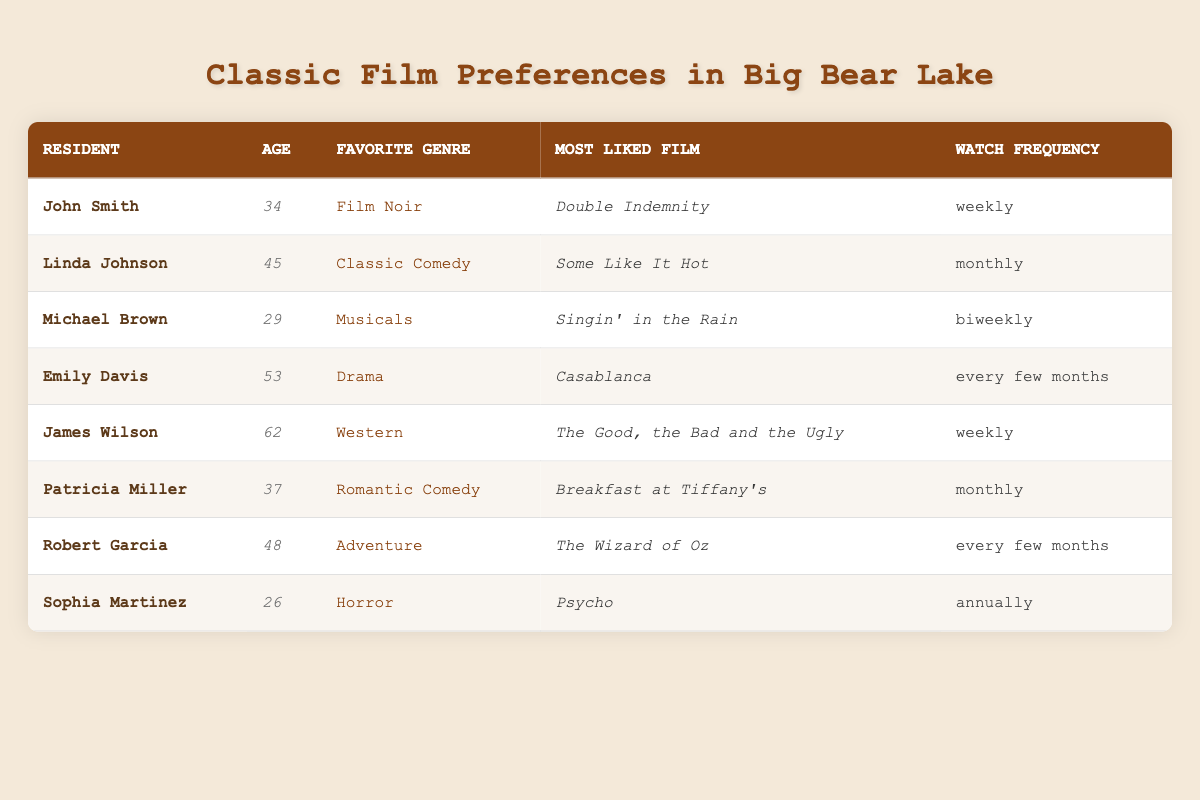What is John Smith's favorite genre? John Smith's favorite genre is listed in the table under the "Favorite Genre" column for his row. The value is "Film Noir".
Answer: Film Noir How many residents prefer Drama as their favorite genre? Looking through the table, only Emily Davis has "Drama" listed as her favorite genre. Therefore, there is just one resident who prefers Drama.
Answer: 1 Which film does Patricia Miller like the most? Patricia Miller's most liked film is found in her row under the "Most Liked Film" column. The value is "Breakfast at Tiffany's".
Answer: Breakfast at Tiffany's Is there anyone who watches films annually? Sophia Martinez has "Annually" listed in the "Watch Frequency" column. Thus, there is indeed a resident who watches films annually.
Answer: Yes What is the average age of residents who watch films weekly? The residents who watch films weekly are John Smith (34) and James Wilson (62). The ages are summed (34 + 62 = 96) and then averaged (96 / 2 = 48).
Answer: 48 Which genre has the highest frequency of watching films among the residents listed? The residents watching films weekly are John Smith (Film Noir) and James Wilson (Western), while Linda Johnson and Patricia Miller watch monthly (Classic Comedy and Romantic Comedy), and others have lesser frequencies. Therefore, the genres with the highest frequency are Film Noir and Western with a frequency of weekly.
Answer: Film Noir and Western What is the most common favorite genre among the surveyed residents? Counting the preferences in the table: Film Noir, Classic Comedy, Musicals, Drama, Western, Romantic Comedy, Adventure, and Horror are the genres. Each genre is unique to its resident, thus there isn't a common genre across multiple residents. Each genre is represented once.
Answer: No common genre How many residents were surveyed in total? Count the number of rows in the table under the "survey_results". There are a total of 8 residents listed.
Answer: 8 What is the most liked film in the Drama genre? Upon checking, "Casablanca" is the most liked film under the preference of Drama by Emily Davis listed in the "Most Liked Film" column.
Answer: Casablanca 